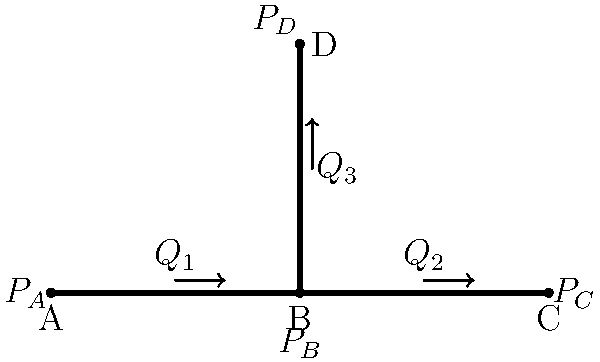In the pipe network shown, water flows from point A to points C and D. Given that the pressure at point A ($P_A$) is 200 kPa, the pressure at point C ($P_C$) is 150 kPa, and the pressure at point D ($P_D$) is 100 kPa, what is the pressure at junction B ($P_B$) in kPa? Assume steady-state flow and neglect any losses due to friction or elevation changes. To solve this problem, we'll use the principle of conservation of energy in fluid flow, specifically the Bernoulli equation. Since we're neglecting friction and elevation changes, we'll focus on the pressure differences.

Step 1: Identify the known pressures:
$P_A = 200$ kPa
$P_C = 150$ kPa
$P_D = 100$ kPa

Step 2: Apply the Bernoulli equation between points A and B, and between B and C:
$P_A - P_B = P_B - P_C$

Step 3: Substitute the known values:
$200 - P_B = P_B - 150$

Step 4: Solve for $P_B$:
$200 - P_B = P_B - 150$
$200 + 150 = 2P_B$
$350 = 2P_B$
$P_B = 175$ kPa

Step 5: Verify the result by checking the pressure difference between B and D:
$P_B - P_D = 175 - 100 = 75$ kPa

This pressure difference is consistent with the overall pressure drop from A to D (200 - 100 = 100 kPa), considering that some pressure is lost between A and B.

Therefore, the pressure at junction B ($P_B$) is 175 kPa.
Answer: 175 kPa 